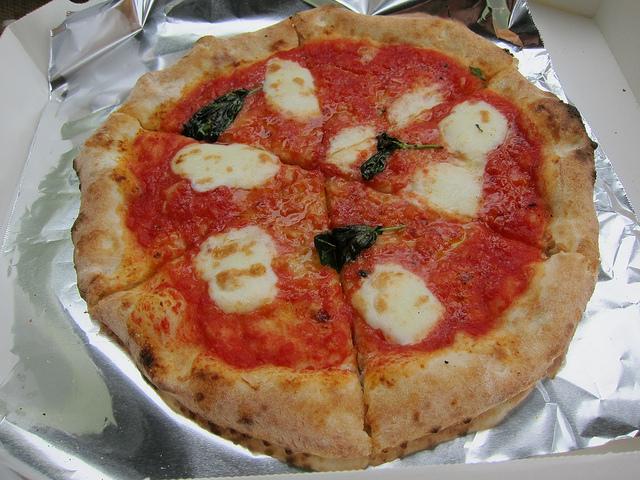What type of pizza is this?
Short answer required. Margarita. Is this breakfast or dinner?
Keep it brief. Dinner. What vegetable is on top of the pizza?
Concise answer only. Spinach. 